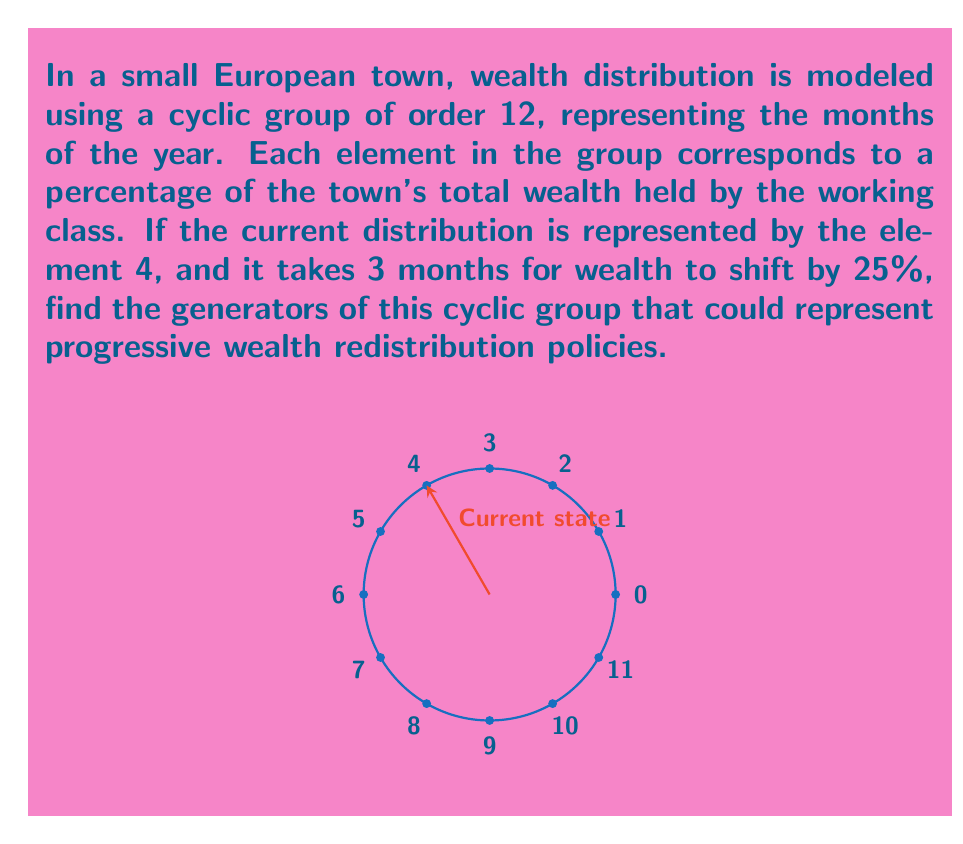Could you help me with this problem? Let's approach this step-by-step:

1) In a cyclic group of order 12, an element $g$ is a generator if and only if $\gcd(g, 12) = 1$.

2) The possible values for $g$ are 1, 2, 3, ..., 11 (we exclude 0 as it doesn't generate the whole group).

3) Let's calculate $\gcd(g, 12)$ for each possible $g$:
   $\gcd(1, 12) = 1$
   $\gcd(2, 12) = 2$
   $\gcd(3, 12) = 3$
   $\gcd(4, 12) = 4$
   $\gcd(5, 12) = 1$
   $\gcd(6, 12) = 6$
   $\gcd(7, 12) = 1$
   $\gcd(8, 12) = 4$
   $\gcd(9, 12) = 3$
   $\gcd(10, 12) = 2$
   $\gcd(11, 12) = 1$

4) From this, we see that the generators are 1, 5, 7, and 11.

5) Now, we need to interpret these in the context of wealth redistribution:
   - A generator of 1 means wealth shifts by 25% every 3 months.
   - A generator of 5 means wealth shifts by 125% every 3 months.
   - A generator of 7 means wealth shifts by 175% every 3 months.
   - A generator of 11 means wealth shifts by 275% every 3 months.

6) Since we're looking for progressive redistribution policies, we should focus on the positive shifts that occur more frequently. This suggests that 1 and 5 are the most suitable generators for modeling progressive wealth redistribution.
Answer: $1$ and $5$ 